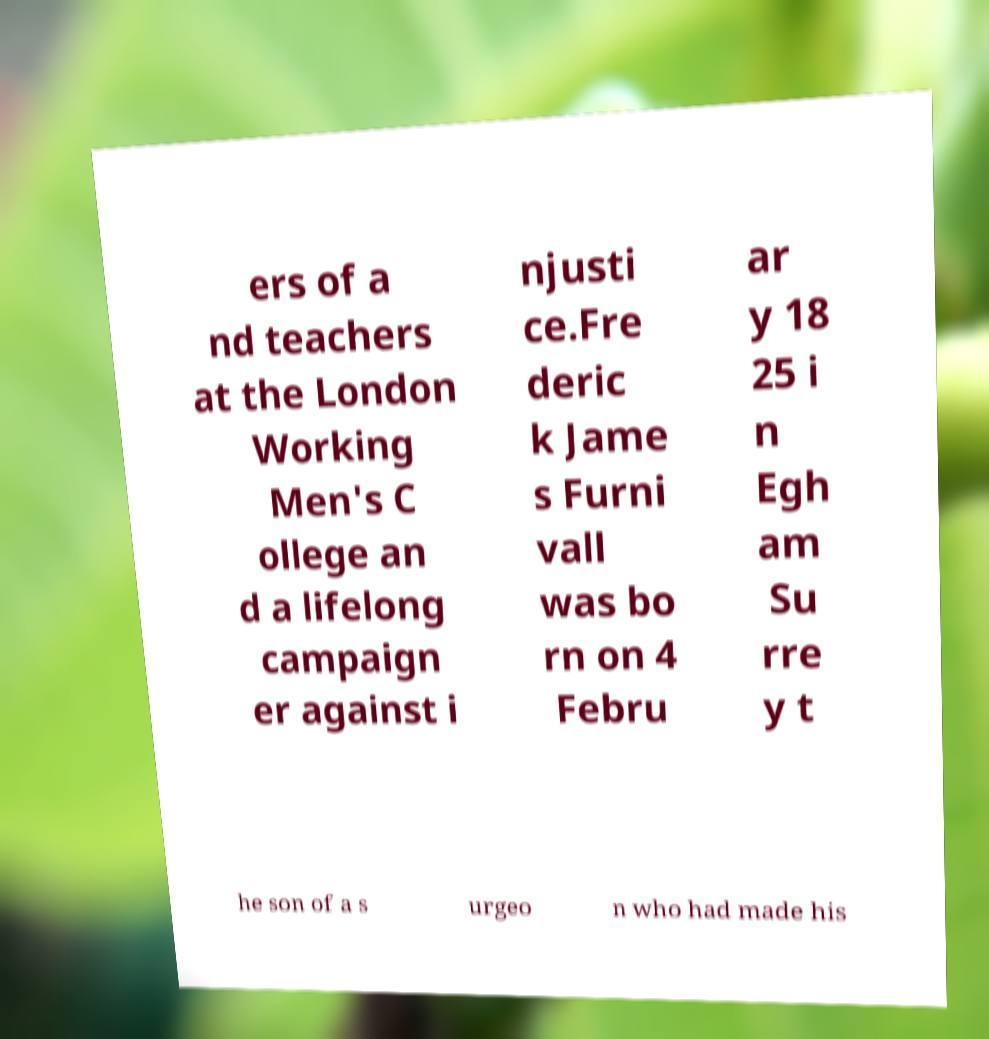For documentation purposes, I need the text within this image transcribed. Could you provide that? ers of a nd teachers at the London Working Men's C ollege an d a lifelong campaign er against i njusti ce.Fre deric k Jame s Furni vall was bo rn on 4 Febru ar y 18 25 i n Egh am Su rre y t he son of a s urgeo n who had made his 